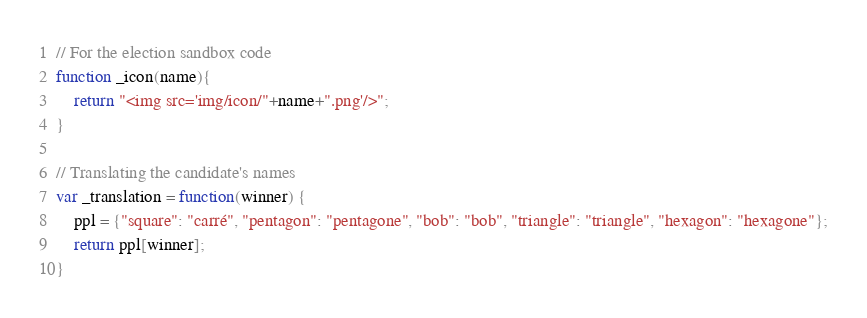Convert code to text. <code><loc_0><loc_0><loc_500><loc_500><_JavaScript_>// For the election sandbox code
function _icon(name){
	return "<img src='img/icon/"+name+".png'/>";
}

// Translating the candidate's names
var _translation = function(winner) {
	ppl = {"square": "carré", "pentagon": "pentagone", "bob": "bob", "triangle": "triangle", "hexagon": "hexagone"};
	return ppl[winner];
}
</code> 